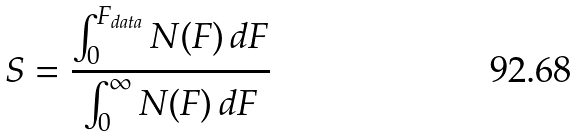<formula> <loc_0><loc_0><loc_500><loc_500>S = \frac { \int _ { 0 } ^ { F _ { d a t a } } N ( F ) \, d F } { \int _ { 0 } ^ { \infty } N ( F ) \, d F }</formula> 